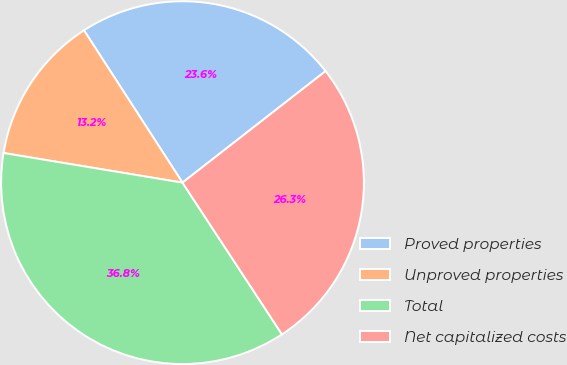Convert chart. <chart><loc_0><loc_0><loc_500><loc_500><pie_chart><fcel>Proved properties<fcel>Unproved properties<fcel>Total<fcel>Net capitalized costs<nl><fcel>23.6%<fcel>13.25%<fcel>36.85%<fcel>26.3%<nl></chart> 